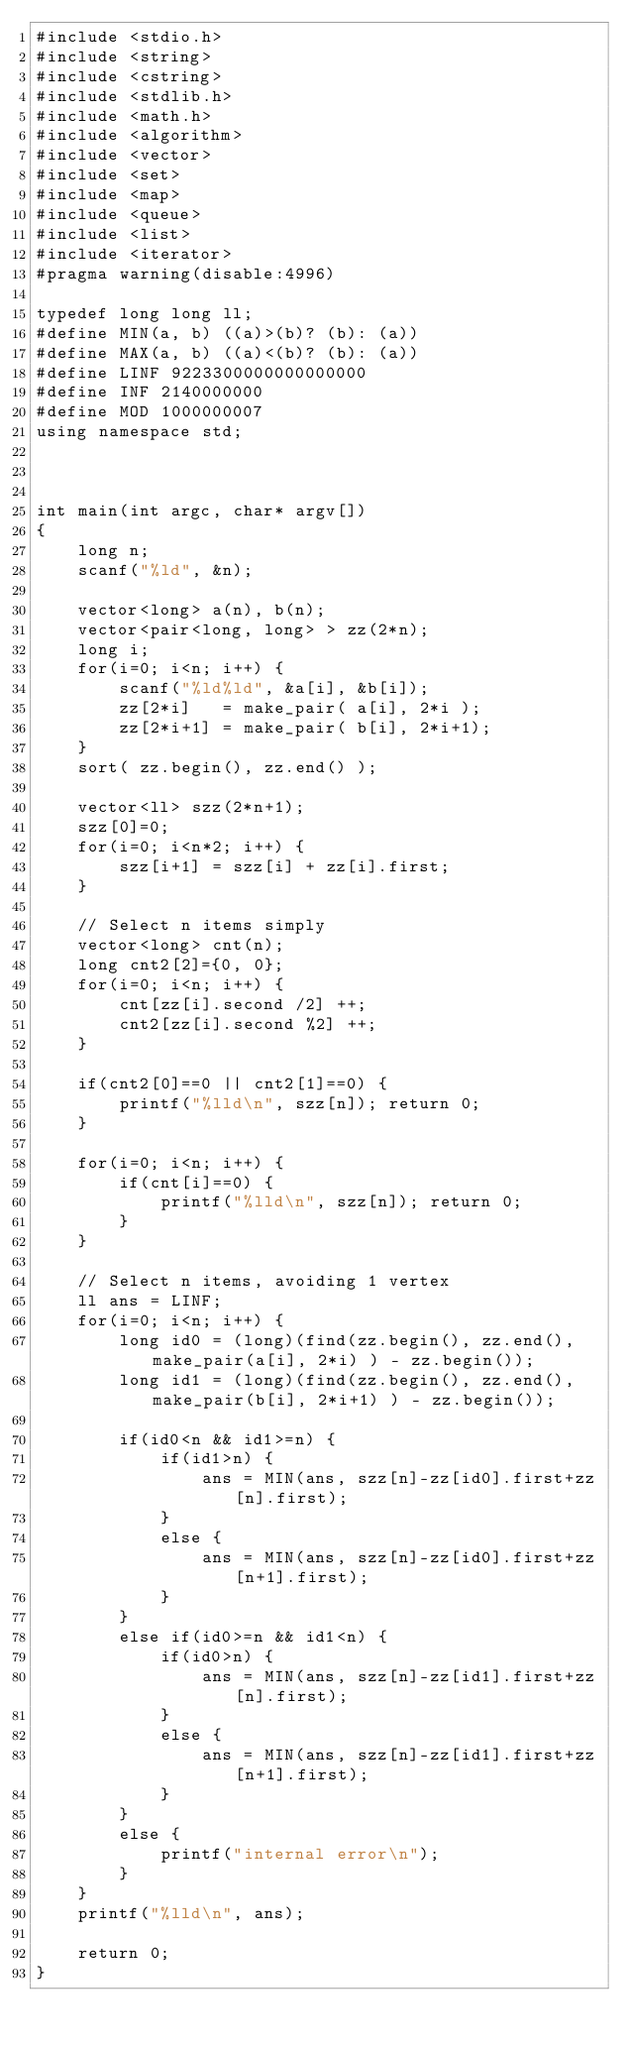Convert code to text. <code><loc_0><loc_0><loc_500><loc_500><_C++_>#include <stdio.h>
#include <string>
#include <cstring>
#include <stdlib.h>
#include <math.h>
#include <algorithm>
#include <vector>
#include <set>
#include <map>
#include <queue>
#include <list>
#include <iterator>
#pragma warning(disable:4996)
 
typedef long long ll;
#define MIN(a, b) ((a)>(b)? (b): (a))
#define MAX(a, b) ((a)<(b)? (b): (a))
#define LINF 9223300000000000000
#define INF 2140000000
#define MOD 1000000007
using namespace std;



int main(int argc, char* argv[])
{
    long n;
    scanf("%ld", &n);

    vector<long> a(n), b(n);
    vector<pair<long, long> > zz(2*n);
    long i;
    for(i=0; i<n; i++) {
        scanf("%ld%ld", &a[i], &b[i]);
        zz[2*i]   = make_pair( a[i], 2*i );
        zz[2*i+1] = make_pair( b[i], 2*i+1);
    }
    sort( zz.begin(), zz.end() );

    vector<ll> szz(2*n+1);
    szz[0]=0;
    for(i=0; i<n*2; i++) {
        szz[i+1] = szz[i] + zz[i].first;
    }

    // Select n items simply
    vector<long> cnt(n); 
    long cnt2[2]={0, 0};
    for(i=0; i<n; i++) {
        cnt[zz[i].second /2] ++;
        cnt2[zz[i].second %2] ++;
    }

    if(cnt2[0]==0 || cnt2[1]==0) {
        printf("%lld\n", szz[n]); return 0;
    }

    for(i=0; i<n; i++) {
        if(cnt[i]==0) {
            printf("%lld\n", szz[n]); return 0;
        }
    }

    // Select n items, avoiding 1 vertex
    ll ans = LINF;
    for(i=0; i<n; i++) {
        long id0 = (long)(find(zz.begin(), zz.end(), make_pair(a[i], 2*i) ) - zz.begin());
        long id1 = (long)(find(zz.begin(), zz.end(), make_pair(b[i], 2*i+1) ) - zz.begin());

        if(id0<n && id1>=n) {
            if(id1>n) {
                ans = MIN(ans, szz[n]-zz[id0].first+zz[n].first);
            }
            else {
                ans = MIN(ans, szz[n]-zz[id0].first+zz[n+1].first);
            }
        }
        else if(id0>=n && id1<n) {
            if(id0>n) {
                ans = MIN(ans, szz[n]-zz[id1].first+zz[n].first);
            }
            else {
                ans = MIN(ans, szz[n]-zz[id1].first+zz[n+1].first);
            }
        }
        else {
            printf("internal error\n");
        }
    }
    printf("%lld\n", ans);

    return 0;
}

</code> 